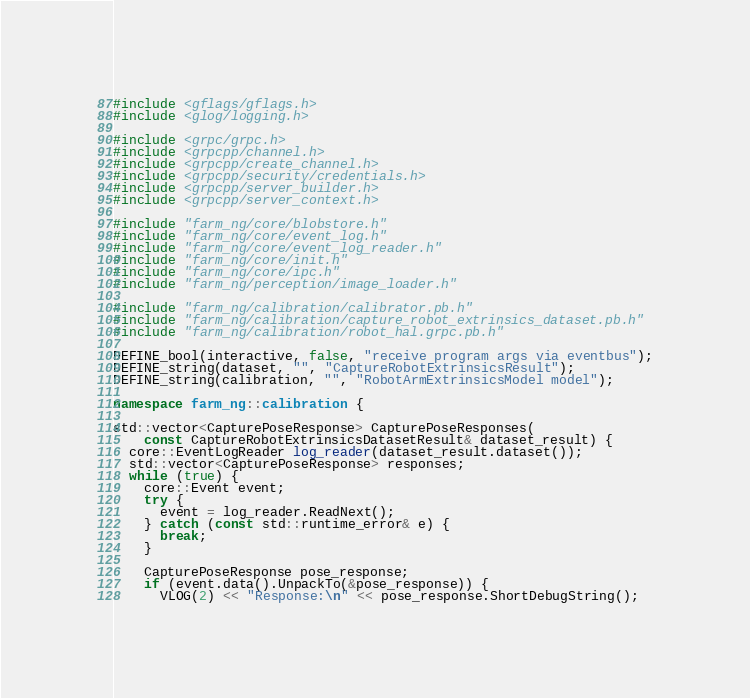<code> <loc_0><loc_0><loc_500><loc_500><_C++_>#include <gflags/gflags.h>
#include <glog/logging.h>

#include <grpc/grpc.h>
#include <grpcpp/channel.h>
#include <grpcpp/create_channel.h>
#include <grpcpp/security/credentials.h>
#include <grpcpp/server_builder.h>
#include <grpcpp/server_context.h>

#include "farm_ng/core/blobstore.h"
#include "farm_ng/core/event_log.h"
#include "farm_ng/core/event_log_reader.h"
#include "farm_ng/core/init.h"
#include "farm_ng/core/ipc.h"
#include "farm_ng/perception/image_loader.h"

#include "farm_ng/calibration/calibrator.pb.h"
#include "farm_ng/calibration/capture_robot_extrinsics_dataset.pb.h"
#include "farm_ng/calibration/robot_hal.grpc.pb.h"

DEFINE_bool(interactive, false, "receive program args via eventbus");
DEFINE_string(dataset, "", "CaptureRobotExtrinsicsResult");
DEFINE_string(calibration, "", "RobotArmExtrinsicsModel model");

namespace farm_ng::calibration {

std::vector<CapturePoseResponse> CapturePoseResponses(
    const CaptureRobotExtrinsicsDatasetResult& dataset_result) {
  core::EventLogReader log_reader(dataset_result.dataset());
  std::vector<CapturePoseResponse> responses;
  while (true) {
    core::Event event;
    try {
      event = log_reader.ReadNext();
    } catch (const std::runtime_error& e) {
      break;
    }

    CapturePoseResponse pose_response;
    if (event.data().UnpackTo(&pose_response)) {
      VLOG(2) << "Response:\n" << pose_response.ShortDebugString();</code> 